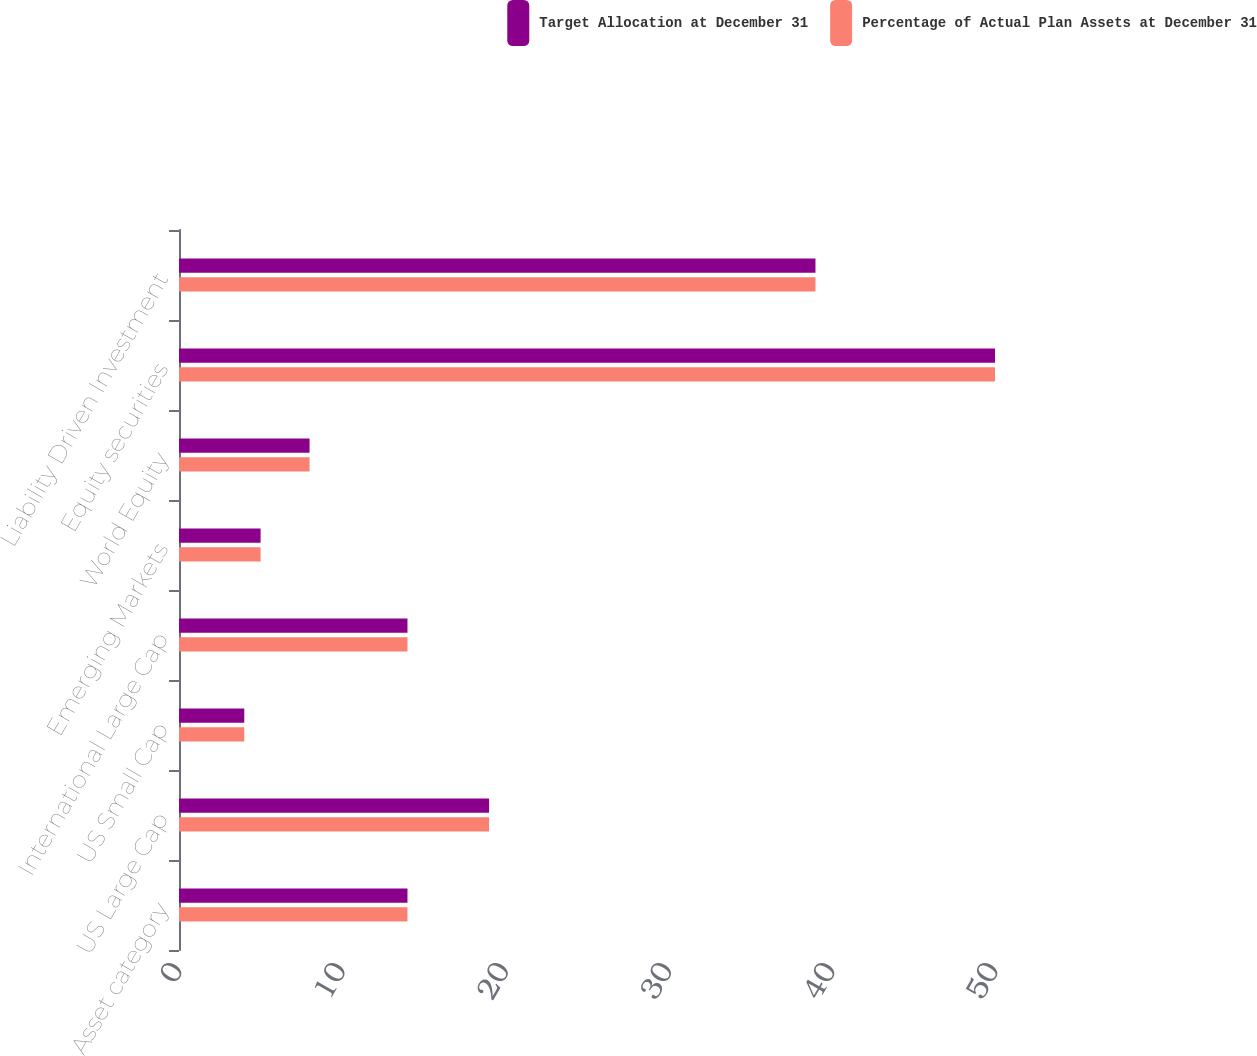Convert chart. <chart><loc_0><loc_0><loc_500><loc_500><stacked_bar_chart><ecel><fcel>Asset category<fcel>US Large Cap<fcel>US Small Cap<fcel>International Large Cap<fcel>Emerging Markets<fcel>World Equity<fcel>Equity securities<fcel>Liability Driven Investment<nl><fcel>Target Allocation at December 31<fcel>14<fcel>19<fcel>4<fcel>14<fcel>5<fcel>8<fcel>50<fcel>39<nl><fcel>Percentage of Actual Plan Assets at December 31<fcel>14<fcel>19<fcel>4<fcel>14<fcel>5<fcel>8<fcel>50<fcel>39<nl></chart> 